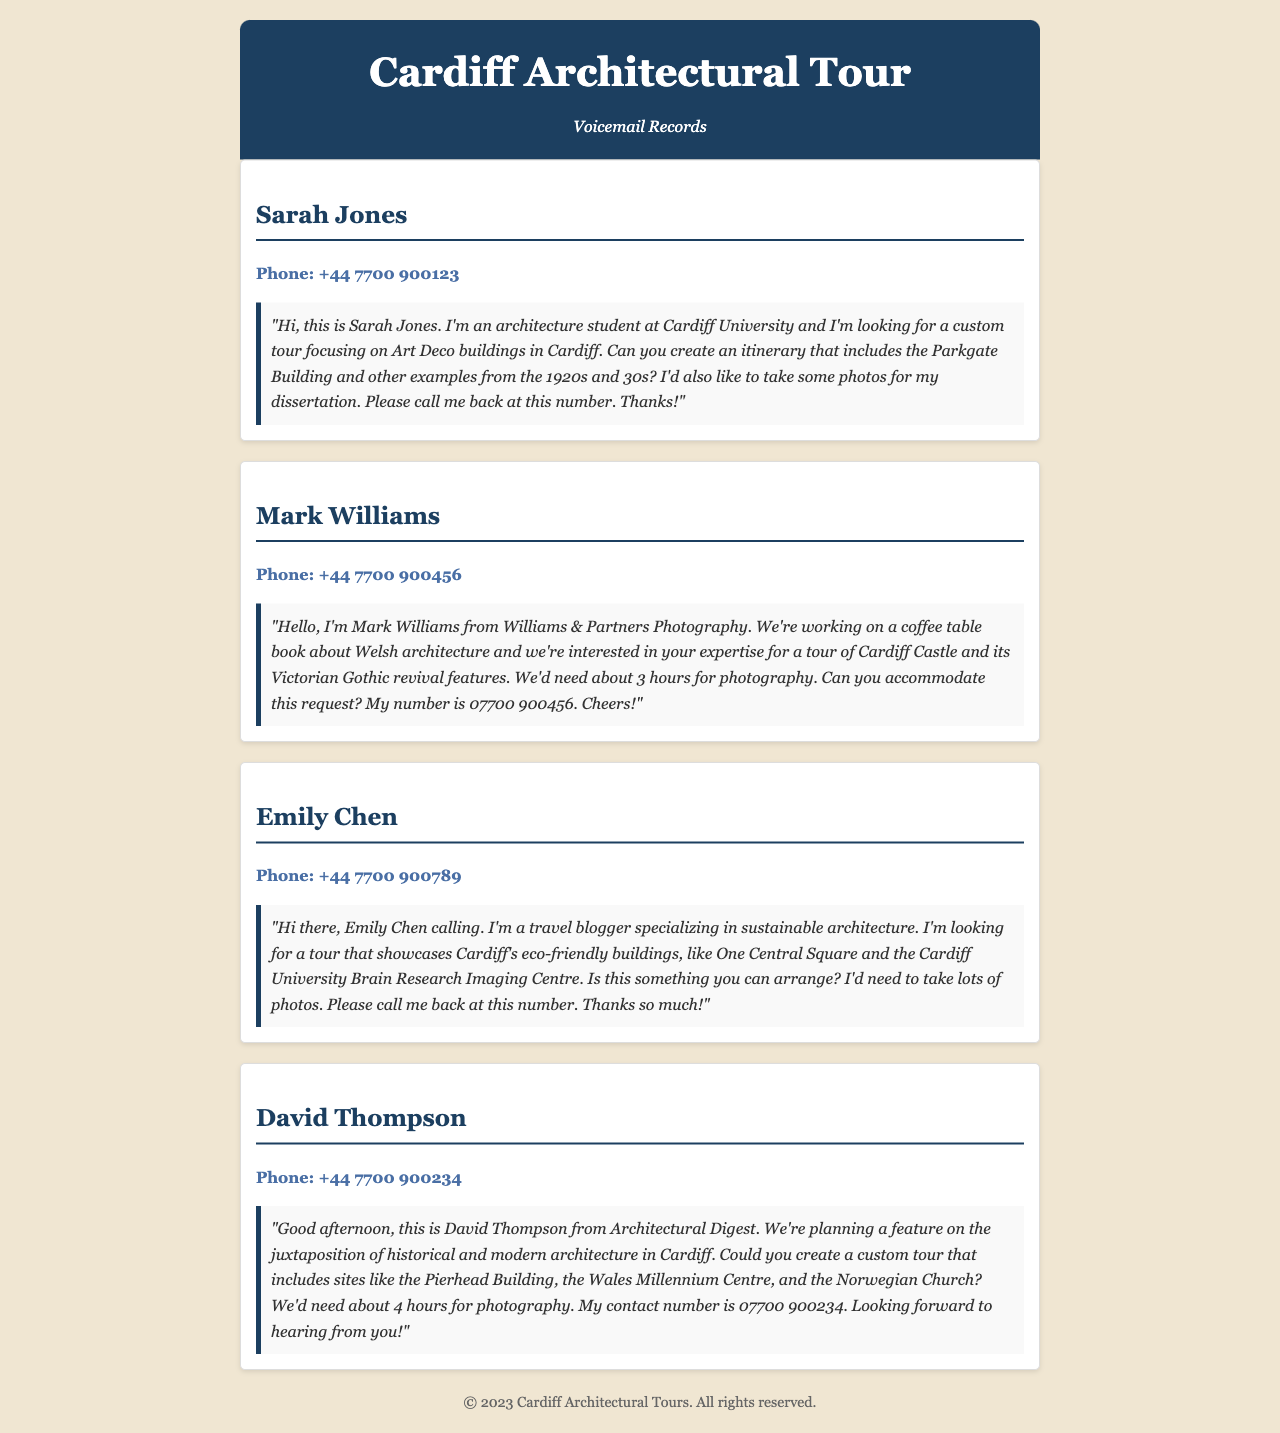What is the name of the first caller? The first caller in the document is Sarah Jones, as indicated in the voicemail record.
Answer: Sarah Jones What is the phone number of Mark Williams? Mark Williams's phone number is provided in his voicemail record, which is +44 7700 900456.
Answer: +44 7700 900456 How many hours does David Thompson need for the custom tour? David Thompson mentioned in his message that he would need about 4 hours for photography.
Answer: 4 hours What specific architectural style does Emily Chen specialize in? Emily Chen stated she specializes in sustainable architecture, which is part of her travel blogging focus.
Answer: Sustainable architecture Which building did Sarah Jones request to include in her tour? Sarah Jones specifically requested the Parkgate Building to be included in her custom tour itinerary.
Answer: Parkgate Building What is the main focus of the project mentioned by Mark Williams? Mark Williams mentioned that his project is a coffee table book about Welsh architecture.
Answer: Welsh architecture Which two specific buildings did Emily Chen want to include in her photography? Emily Chen requested to visit One Central Square and the Cardiff University Brain Research Imaging Centre for her photography.
Answer: One Central Square and the Cardiff University Brain Research Imaging Centre How did David Thompson refer to the publication he represents? David Thompson mentioned that he is from Architectural Digest, indicating the publication he refers to in his voicemail.
Answer: Architectural Digest What is the duration of the requested custom tour from Mark Williams? Mark Williams requests a duration of about 3 hours for his photography tour of Cardiff Castle.
Answer: 3 hours 